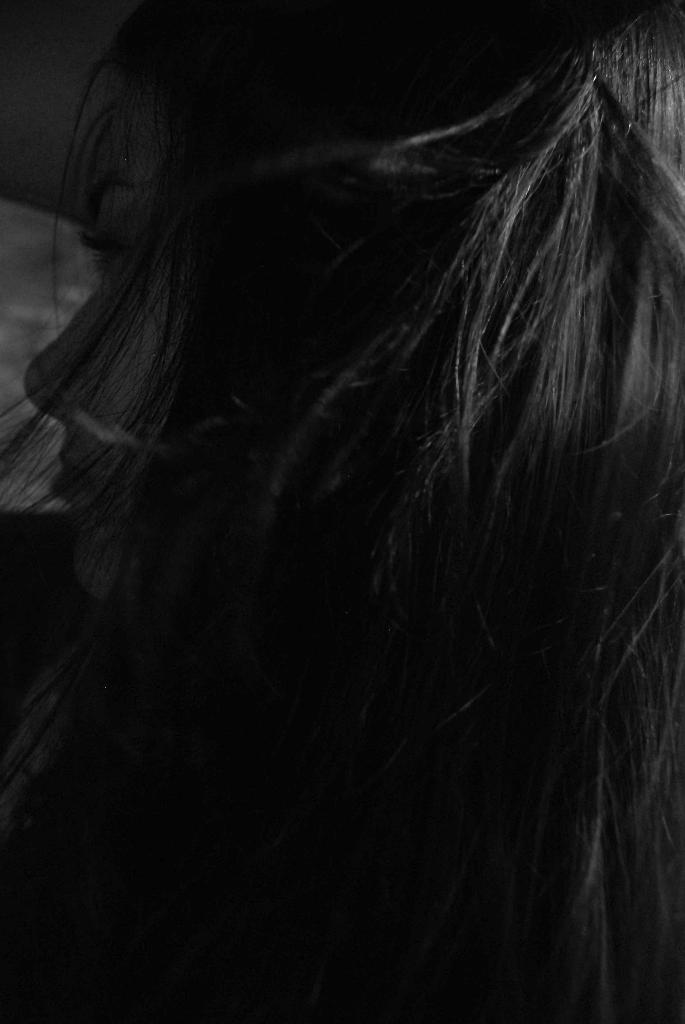Who is present in the image? There is a woman in the image. What type of river can be heard flowing in the background of the image? There is no river present in the image, nor is there any sound of a river. 